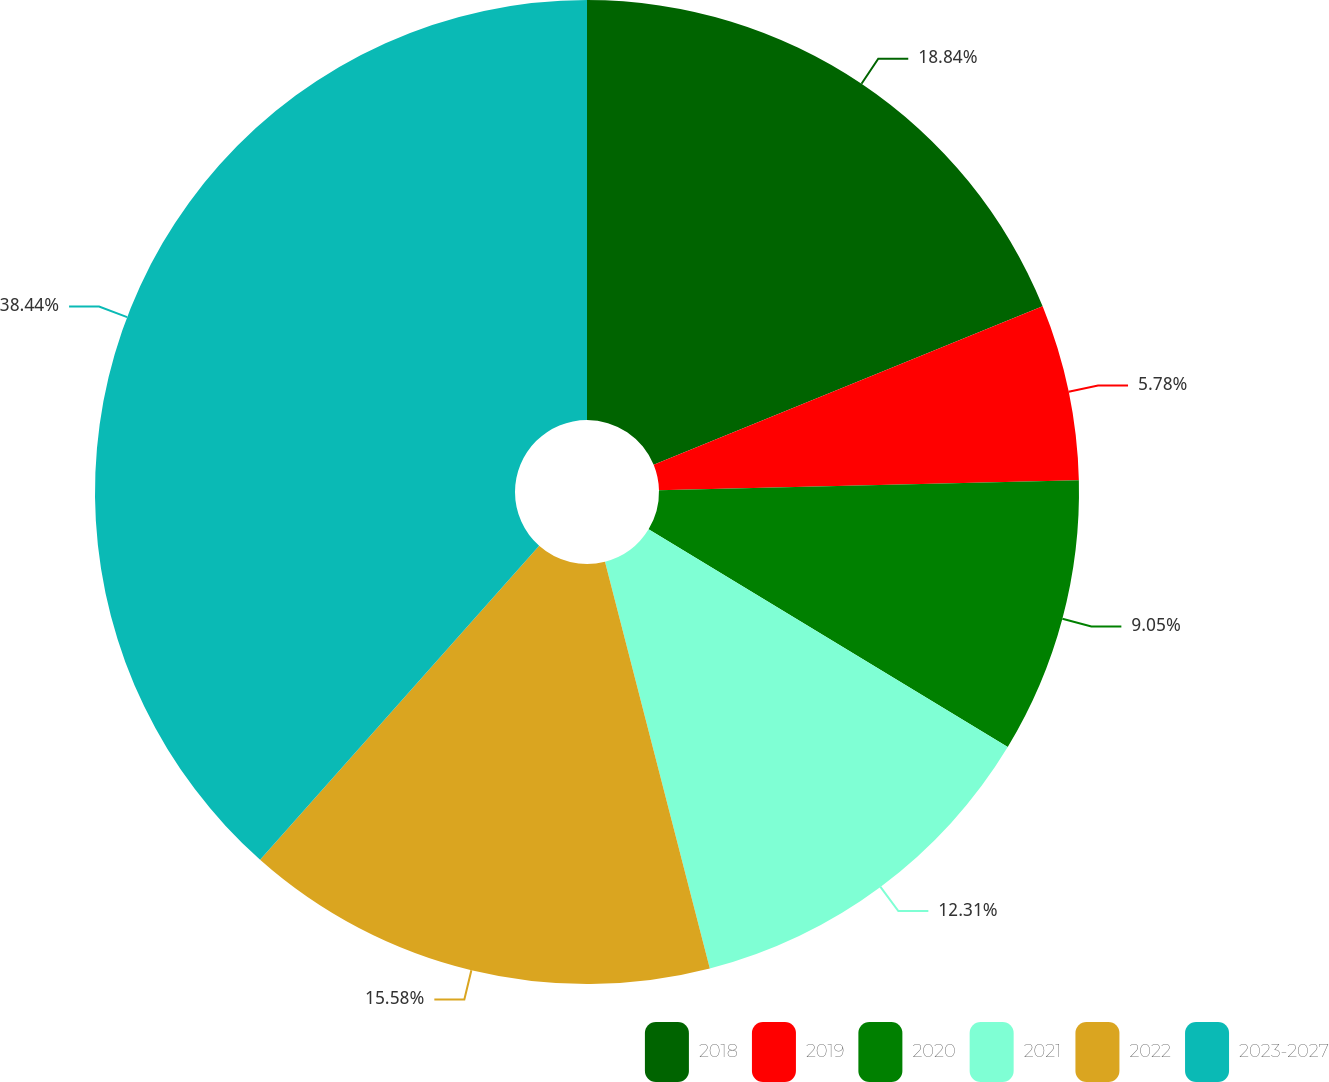Convert chart. <chart><loc_0><loc_0><loc_500><loc_500><pie_chart><fcel>2018<fcel>2019<fcel>2020<fcel>2021<fcel>2022<fcel>2023-2027<nl><fcel>18.84%<fcel>5.78%<fcel>9.05%<fcel>12.31%<fcel>15.58%<fcel>38.43%<nl></chart> 